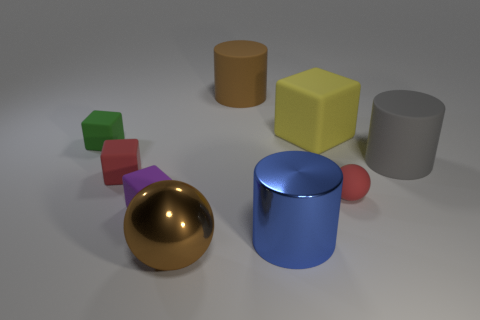Subtract all large matte cylinders. How many cylinders are left? 1 Subtract all red cubes. How many cubes are left? 3 Add 1 big brown rubber things. How many objects exist? 10 Subtract all brown blocks. Subtract all purple spheres. How many blocks are left? 4 Subtract all spheres. How many objects are left? 7 Subtract 0 yellow spheres. How many objects are left? 9 Subtract all brown cylinders. Subtract all matte objects. How many objects are left? 1 Add 6 green cubes. How many green cubes are left? 7 Add 3 big yellow matte blocks. How many big yellow matte blocks exist? 4 